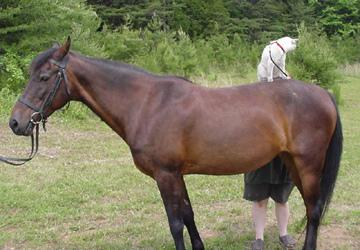What direction is the horse facing? The horse is facing left. Is the horse moving or standing still?  The horse is standing still. What kind of vegetation is present in the background of the image? Green grass and trees are growing in the background. Is there another animal besides the horse and cat mentioned in the image, and if so, what is it? Yes, a small dog or puppy is seated on the hind quarters of the horse. What kind of animal is interacting with the horse? A white cat is sitting on the brown horse. What is unique about the white cat's appearance? The white cat is wearing a collar and has a leash on. Describe the clothing of the person standing in the scene. The person is wearing sandals and a pair of shorts. What is a key feature of the horse's appearance that's mentioned? The horse has long hair on top of its head. Mention the position and color of the person in respect to the horse. A person stands behind the large brown horse and is obscured by it. What are the two main colors of the animals in the image? The two main colors of the animals are brown (horse) and white (cat). Provide three words that accurately depict the main subjects of the image. Horse, cat, person. Describe the relationship between the white cat and the horse in the image. The white cat is sitting on top of the brown horse and appears to be comfortable together. What is the general setting of the image provided? A grassy field with trees in the background. What color is the horse in the image? Brown In the image, is the white cat looking at the person or the horse? The white cat is looking at the person. Can you see the brown cat sitting near the person? No, it's not mentioned in the image. Is the cat sitting on the horse black and spotted? The cat on the horse is described as white, not black and spotted, so this would lead to confusion when searching for a cat with the wrong attributes. Is the dog on the horse a golden retriever? The image contains a small dog and white puppy, but there is no mention of a golden retriever. So, the viewer might look for a dog that isn't present. Are there purple flowers in the grass beneath the horse? There is no mention of any flowers in the image, let alone purple ones. The viewer would be searching for something that isn't there based on this instruction. Is the horse in the image wearing a harness or a bridal? The horse is wearing a bridal. Based on the image's objects and positions, describe the interaction between the person and the animals. The person is standing behind the horse, partially obscured, while the white cat is on top of the horse. Who is holding the brown horse in the image? The horse is held by a leash. Is the cat wearing a collar in the image? Yes Are there any trees visible in the background of the image? Yes, there are green trees. Create a poetic depiction of the scene shown in the image. In the verdant field, 'neath the foliage serene, a noble steed stands, adorned with a mirthful feline queen. Based on the image provided, which one of the following statements is accurate? a) A white dog is sitting on the horse. b) A person is fully visible next to the horse. c) A white cat is on the horse. d) There are no trees in the background. c) A white cat is on the horse. What type of clothes is the person in the image wearing? The person is wearing a pair of shorts. Create a short story involving the person, the cat, and the horse based on the image. Once upon a sunny day, a kind-hearted person led their gentle giant, the brown horse, and their playful white cat into a lovely grassy field. The curious cat climbed onto the horse, and they stood peacefully together, surrounded by tall green trees. What type of vegetation is shown in the image background? Green grass and trees. What is the nature of the field where the horse is standing in the image? The horse stands in a grassy field. Is the person standing on the horse wearing a cowboy hat? There is no mention of a person standing on the horse at all, nor is there a person wearing a cowboy hat. This instruction would lead the viewer to search for a nonexistent person in the wrong position with incorrect attributes. Write a caption with alliteration to describe the scene portrayed in the image. Cute cat casually perched on a calm, colossal chestnut horse. Describe the footwear that the person in the image is wearing. The person is wearing sandals. 